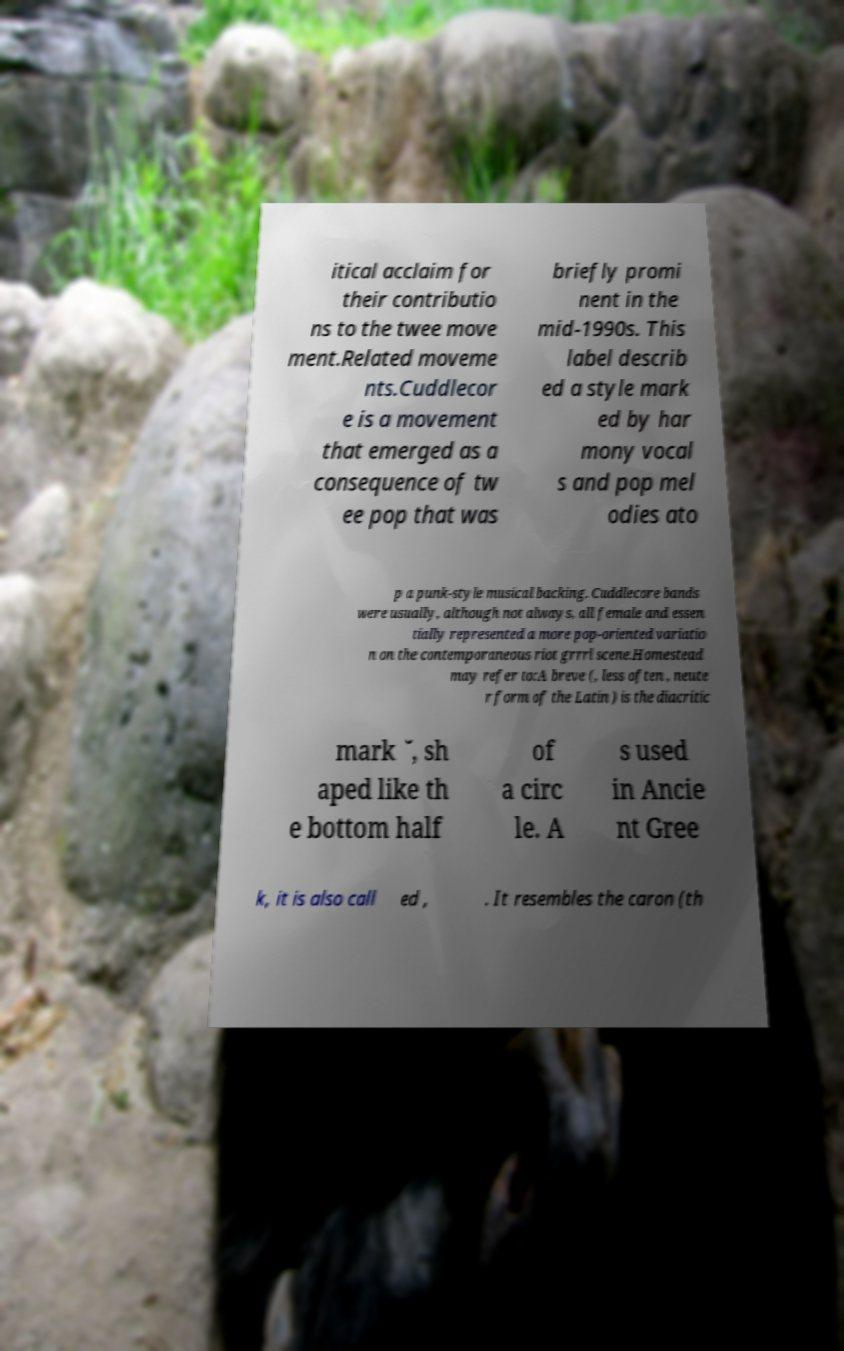For documentation purposes, I need the text within this image transcribed. Could you provide that? itical acclaim for their contributio ns to the twee move ment.Related moveme nts.Cuddlecor e is a movement that emerged as a consequence of tw ee pop that was briefly promi nent in the mid-1990s. This label describ ed a style mark ed by har mony vocal s and pop mel odies ato p a punk-style musical backing. Cuddlecore bands were usually, although not always, all female and essen tially represented a more pop-oriented variatio n on the contemporaneous riot grrrl scene.Homestead may refer to:A breve (, less often , neute r form of the Latin ) is the diacritic mark ˘, sh aped like th e bottom half of a circ le. A s used in Ancie nt Gree k, it is also call ed , . It resembles the caron (th 